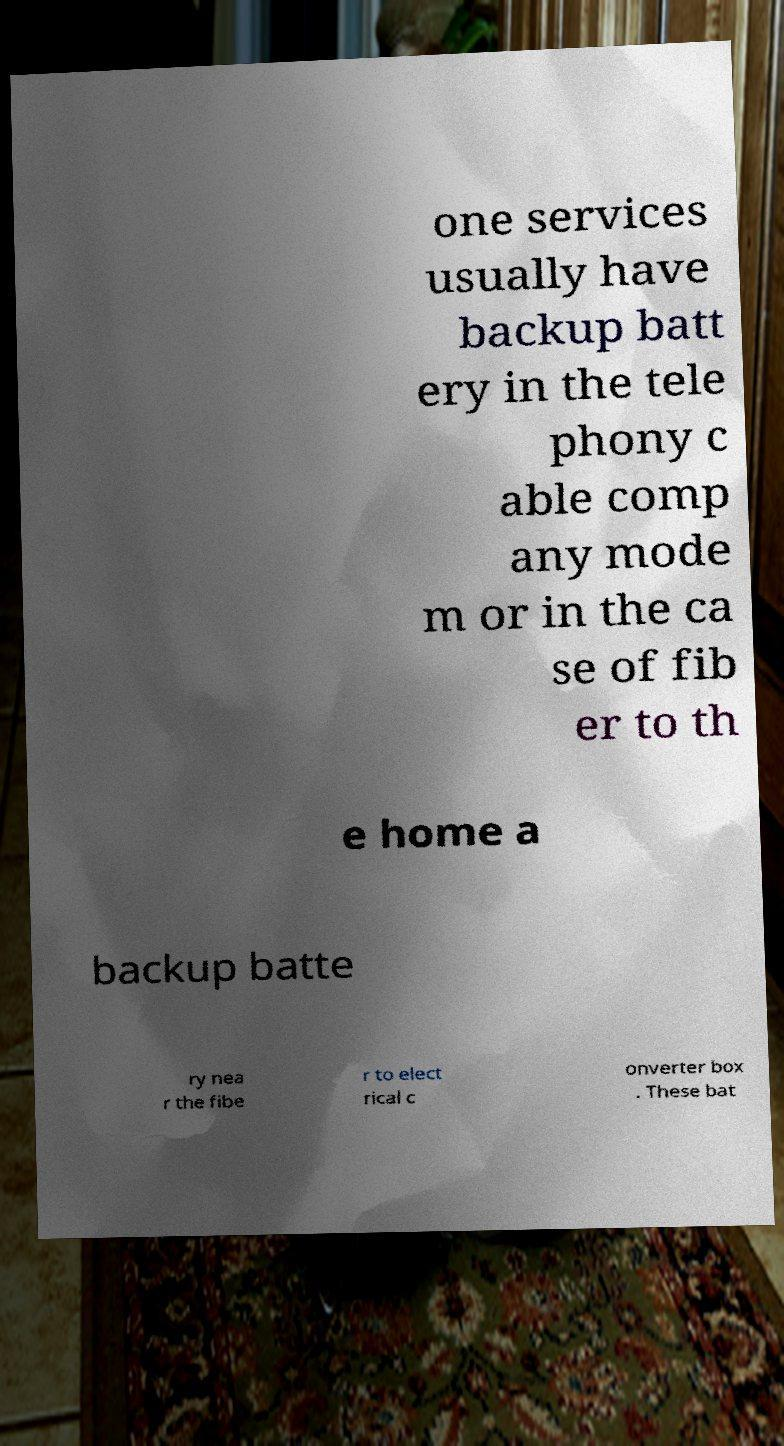For documentation purposes, I need the text within this image transcribed. Could you provide that? one services usually have backup batt ery in the tele phony c able comp any mode m or in the ca se of fib er to th e home a backup batte ry nea r the fibe r to elect rical c onverter box . These bat 